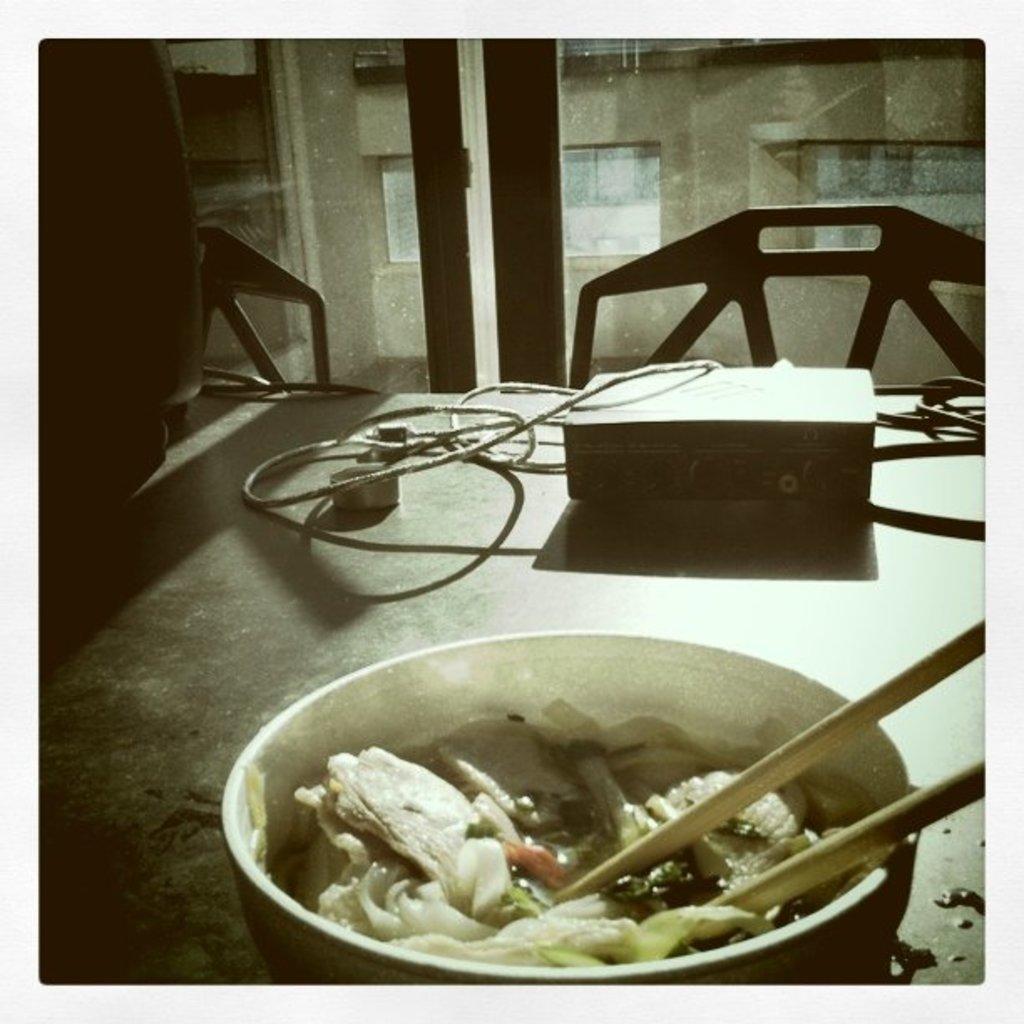In one or two sentences, can you explain what this image depicts? In this picture we can see table and on table we have wires, box, bowl, chopstick and food in bowl and in background we can see glass, window, wall. 